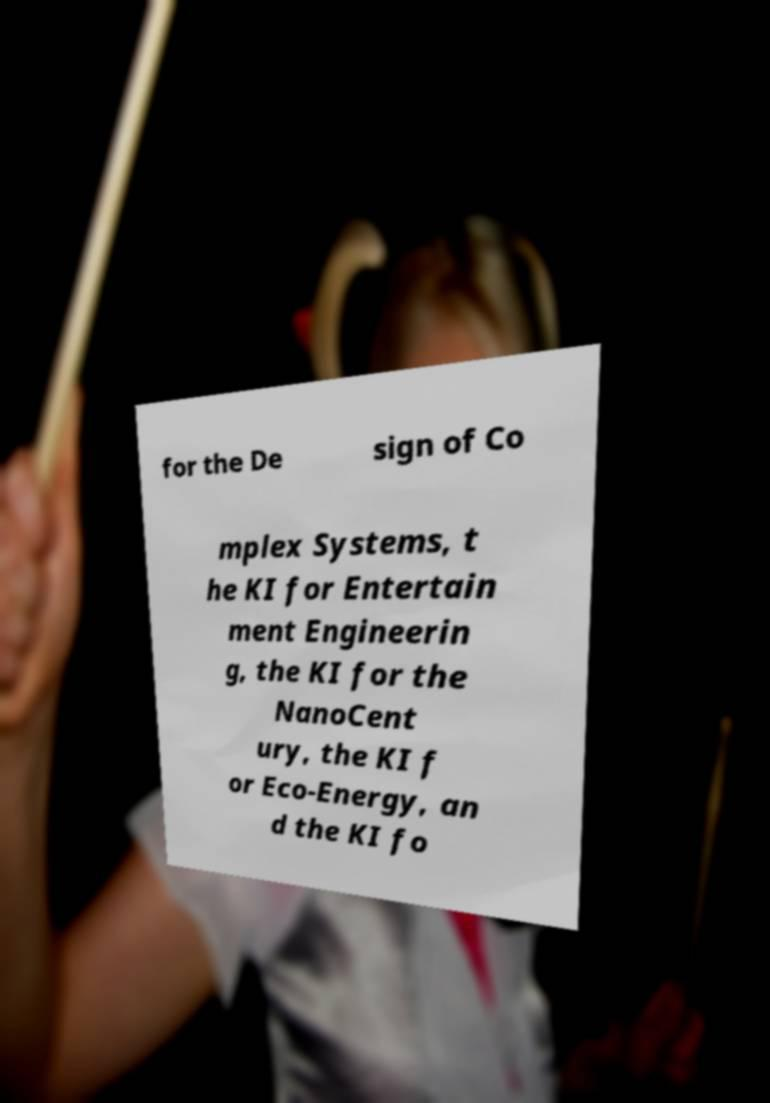Please identify and transcribe the text found in this image. for the De sign of Co mplex Systems, t he KI for Entertain ment Engineerin g, the KI for the NanoCent ury, the KI f or Eco-Energy, an d the KI fo 